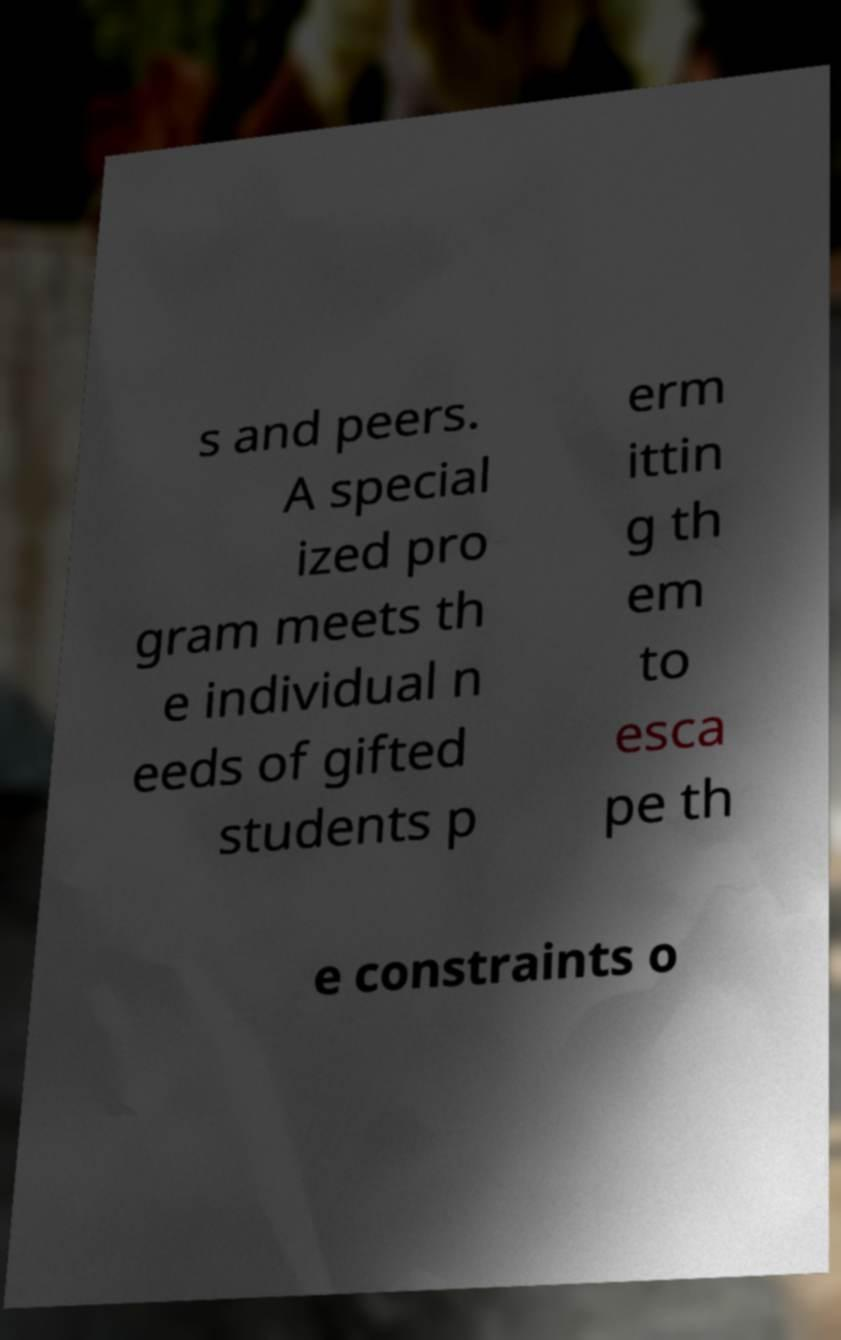I need the written content from this picture converted into text. Can you do that? s and peers. A special ized pro gram meets th e individual n eeds of gifted students p erm ittin g th em to esca pe th e constraints o 